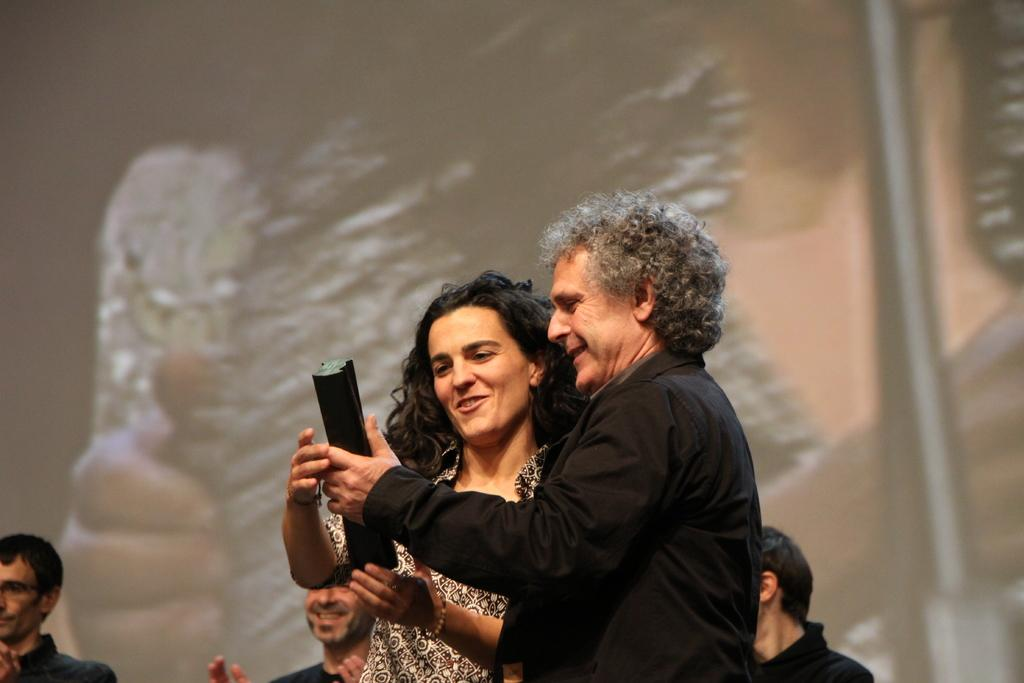How many people are in the image? There are people in the image, but the exact number is not specified. Can you describe the man in the image? There is a man in the image, and he is holding an object. What can be seen in the background of the image? There is a screen visible in the background of the image. What type of mine is the man operating in the image? There is no mine present in the image; it only features people, a man holding an object, and a screen in the background. 